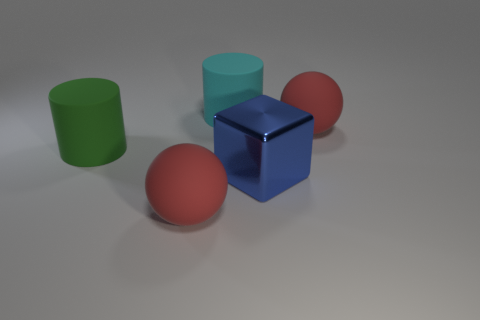Add 4 blue metallic objects. How many objects exist? 9 Subtract all spheres. How many objects are left? 3 Add 2 blue shiny blocks. How many blue shiny blocks are left? 3 Add 3 large metallic things. How many large metallic things exist? 4 Subtract 0 brown balls. How many objects are left? 5 Subtract all green matte objects. Subtract all big cylinders. How many objects are left? 2 